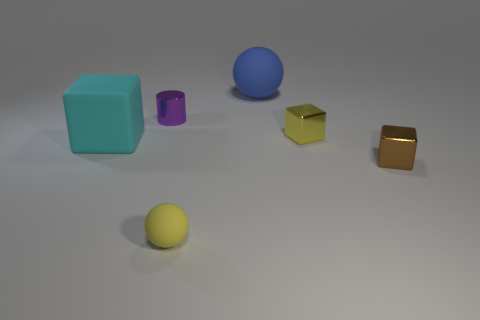Subtract all big matte blocks. How many blocks are left? 2 Add 1 shiny things. How many objects exist? 7 Subtract all balls. How many objects are left? 4 Subtract all red cubes. Subtract all brown spheres. How many cubes are left? 3 Subtract all cubes. Subtract all cyan matte blocks. How many objects are left? 2 Add 6 cylinders. How many cylinders are left? 7 Add 5 red cylinders. How many red cylinders exist? 5 Subtract 0 blue cubes. How many objects are left? 6 